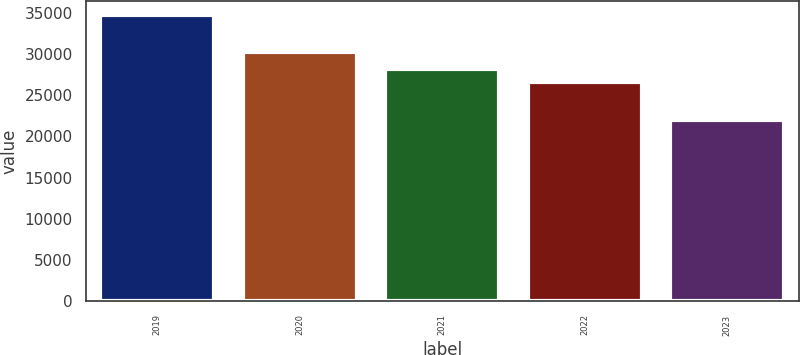Convert chart. <chart><loc_0><loc_0><loc_500><loc_500><bar_chart><fcel>2019<fcel>2020<fcel>2021<fcel>2022<fcel>2023<nl><fcel>34697<fcel>30287<fcel>28111<fcel>26604<fcel>21995<nl></chart> 